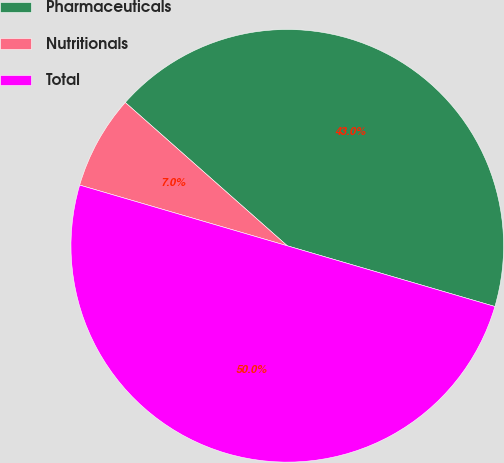Convert chart. <chart><loc_0><loc_0><loc_500><loc_500><pie_chart><fcel>Pharmaceuticals<fcel>Nutritionals<fcel>Total<nl><fcel>43.0%<fcel>7.0%<fcel>50.0%<nl></chart> 